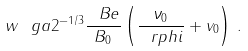Convert formula to latex. <formula><loc_0><loc_0><loc_500><loc_500>w \ g a 2 ^ { - 1 / 3 } \frac { \ B e } { B _ { 0 } } \left ( \frac { \nu _ { 0 } } { \ r p h i } + v _ { 0 } \right ) \, .</formula> 